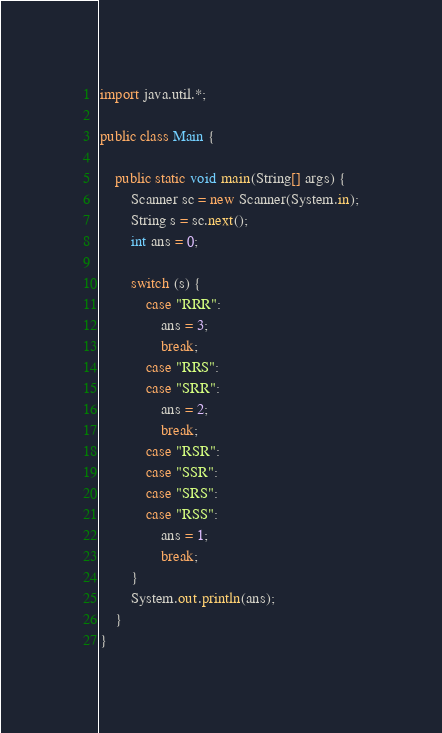Convert code to text. <code><loc_0><loc_0><loc_500><loc_500><_Java_>import java.util.*;

public class Main {

    public static void main(String[] args) {
        Scanner sc = new Scanner(System.in);
        String s = sc.next();
        int ans = 0;

        switch (s) {
            case "RRR":
                ans = 3;
                break;
            case "RRS": 
            case "SRR": 
                ans = 2;
                break;
            case "RSR": 
            case "SSR":
            case "SRS":
            case "RSS":
                ans = 1;
                break;
        }
        System.out.println(ans);
    }
}</code> 